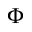Convert formula to latex. <formula><loc_0><loc_0><loc_500><loc_500>\Phi</formula> 